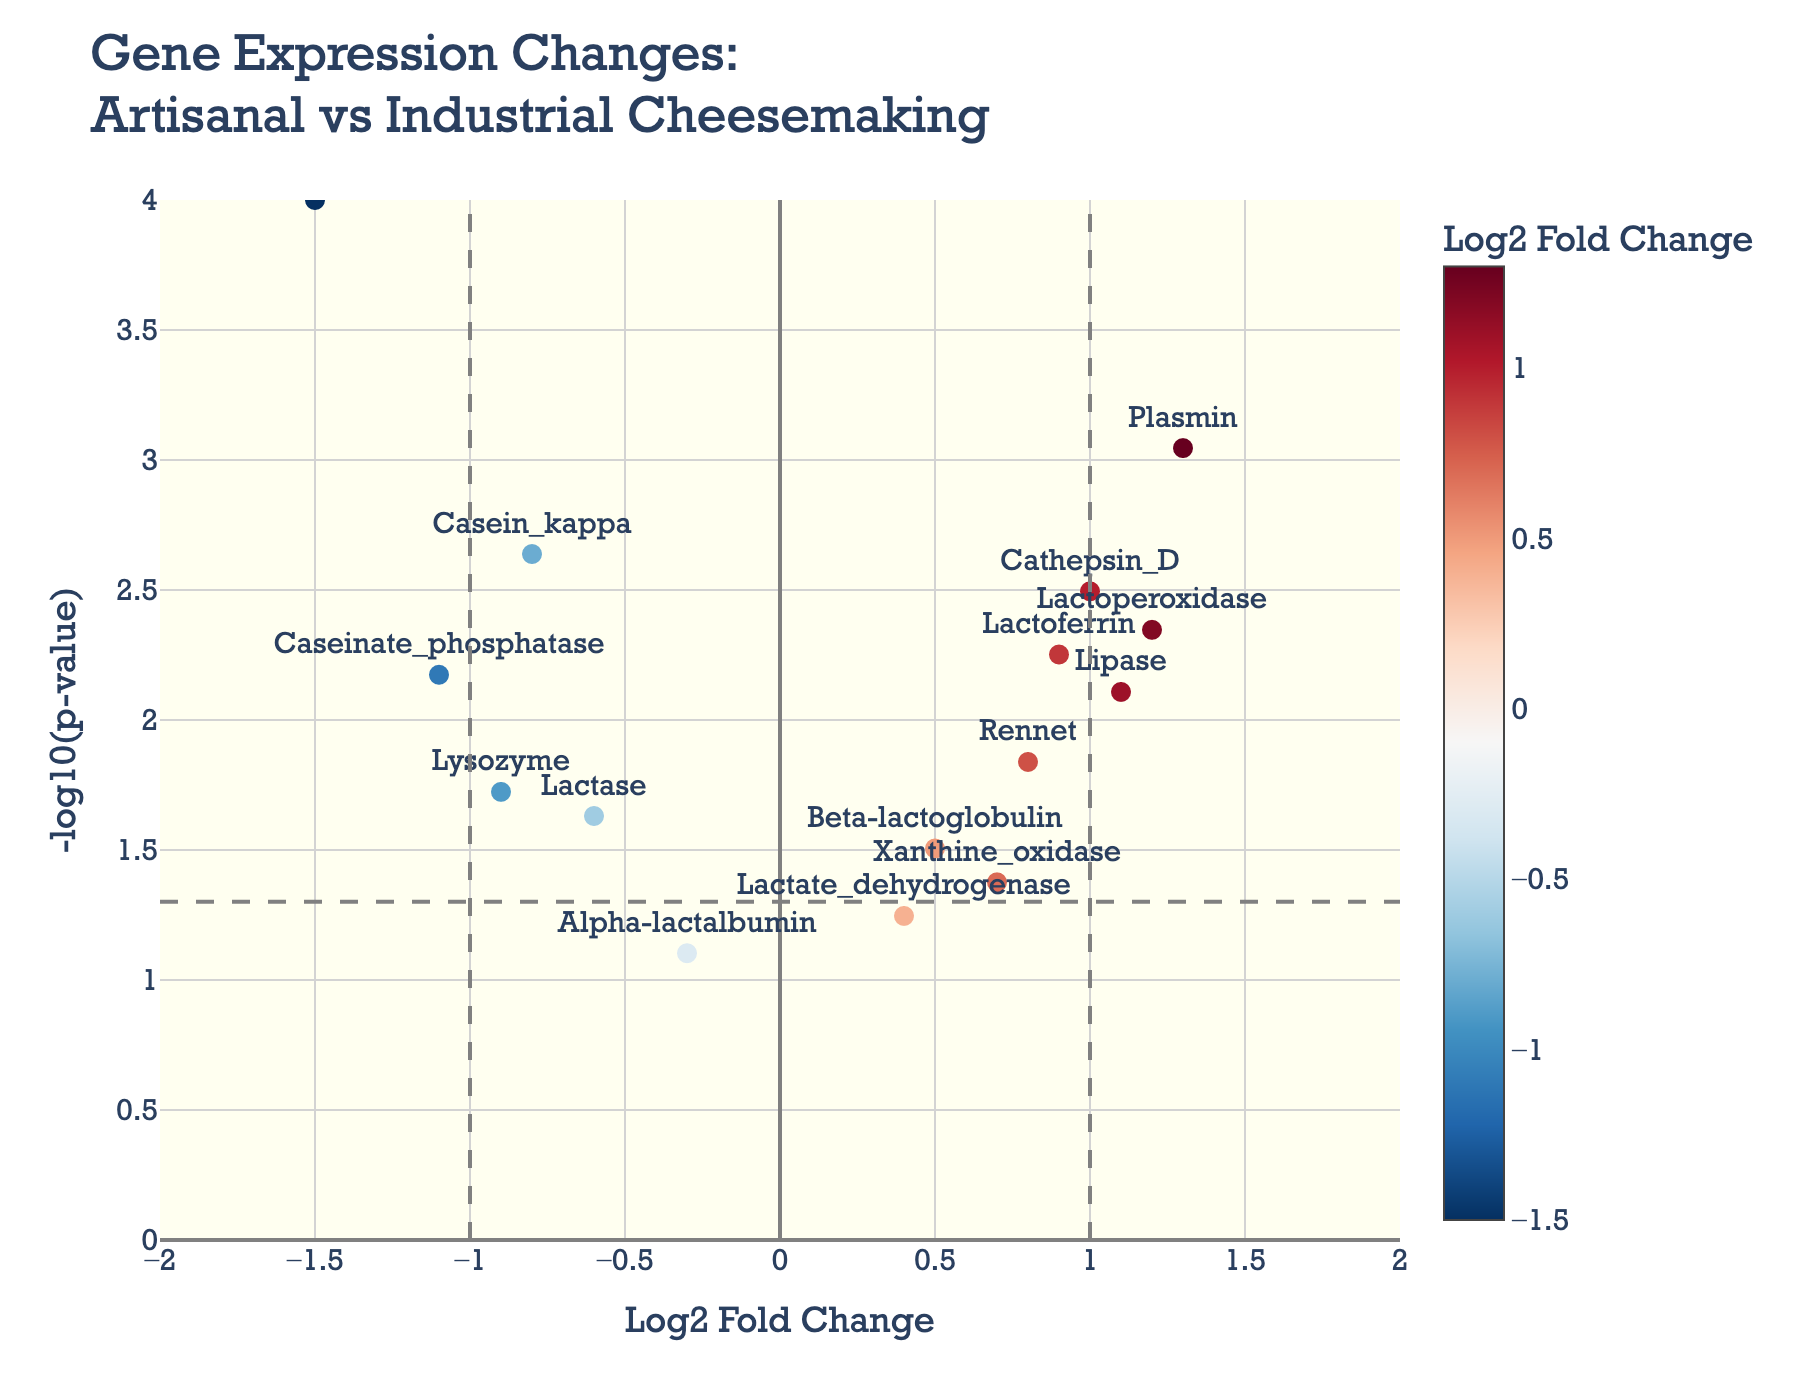How many genes have a Log2 Fold Change greater than 1? First, identify the points that are to the right of the vertical dashed line at Log2 Fold Change = 1. These points are Plasmin, Cathepsin_D, and Lactoperoxidase, indicating that three genes have a Log2 Fold Change greater than 1.
Answer: 3 What is the title of the plot? The title is located at the top of the figure and reads "Gene Expression Changes: Artisanal vs Industrial Cheesemaking."
Answer: Gene Expression Changes: Artisanal vs Industrial Cheesemaking Which gene has the lowest p-value? The p-value is inversely proportional to the y-axis value (-log10(p-value)) in the plot. The highest point on the y-axis belongs to Chymosin, indicating it has the lowest p-value.
Answer: Chymosin What are the x and y axes labeled as? The x-axis label is "Log2 Fold Change," which indicates the fold change in gene expression, and the y-axis label is "-log10(p-value)," representing the significance of the change.
Answer: Log2 Fold Change and -log10(p-value) How many genes have a statistically significant change (p-value < 0.05)? The significance threshold is marked by a horizontal dashed line. All points above this line are statistically significant. These genes are Casein_kappa, Lactoperoxidase, Lactoferrin, Chymosin, Lipase, Lactase, Xanthine_oxidase, Plasmin, Caseinate_phosphatase, Lysozyme, and Cathepsin_D, totaling 11 genes.
Answer: 11 Which gene has the highest Log2 Fold Change? By observing the rightmost points along the x-axis, the gene with the highest Log2 Fold Change is Plasmin.
Answer: Plasmin What color represents genes with a Log2 Fold Change around 0? The color scale from the color bar indicates neutral fold changes around 0 with a middle range color, typically shown in white/light colors.
Answer: White/light Identify a gene that has a Log2 Fold Change less than -1. Points to the left of the vertical dashed line at Log2 Fold Change = -1 fall into this category. The genes are Chymosin and Caseinate_phosphatase.
Answer: Chymosin and Caseinate_phosphatase Compare the significance levels for the genes Chymosin and Lactase. Which one is more significant? Significance is depicted by the y-axis height. Chymosin is significantly higher on the y-axis (-log10(p-value) = 4) compared to Lactase, indicating it is more significant.
Answer: Chymosin What does the vertical dashed line at Log2 Fold Change = 1 signify? The vertical dashed lines at Log2 Fold Change = 1 and Log2 Fold Change = -1 mark threshold values that often indicate meaningful fold changes in gene expression.
Answer: Threshold for meaningful fold change 